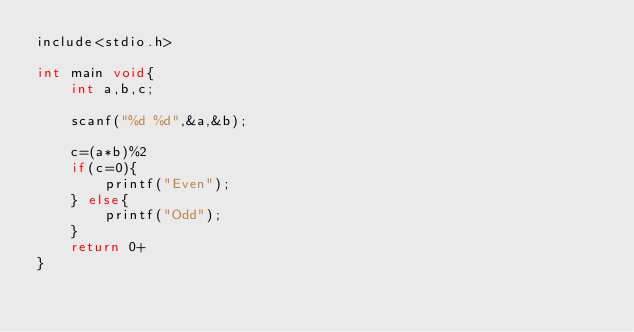Convert code to text. <code><loc_0><loc_0><loc_500><loc_500><_C++_>include<stdio.h>

int main void{
	int a,b,c;
	
	scanf("%d %d",&a,&b);
	
	c=(a*b)%2
	if(c=0){
		printf("Even");
	} else{
		printf("Odd");
	}
	return 0+
}</code> 